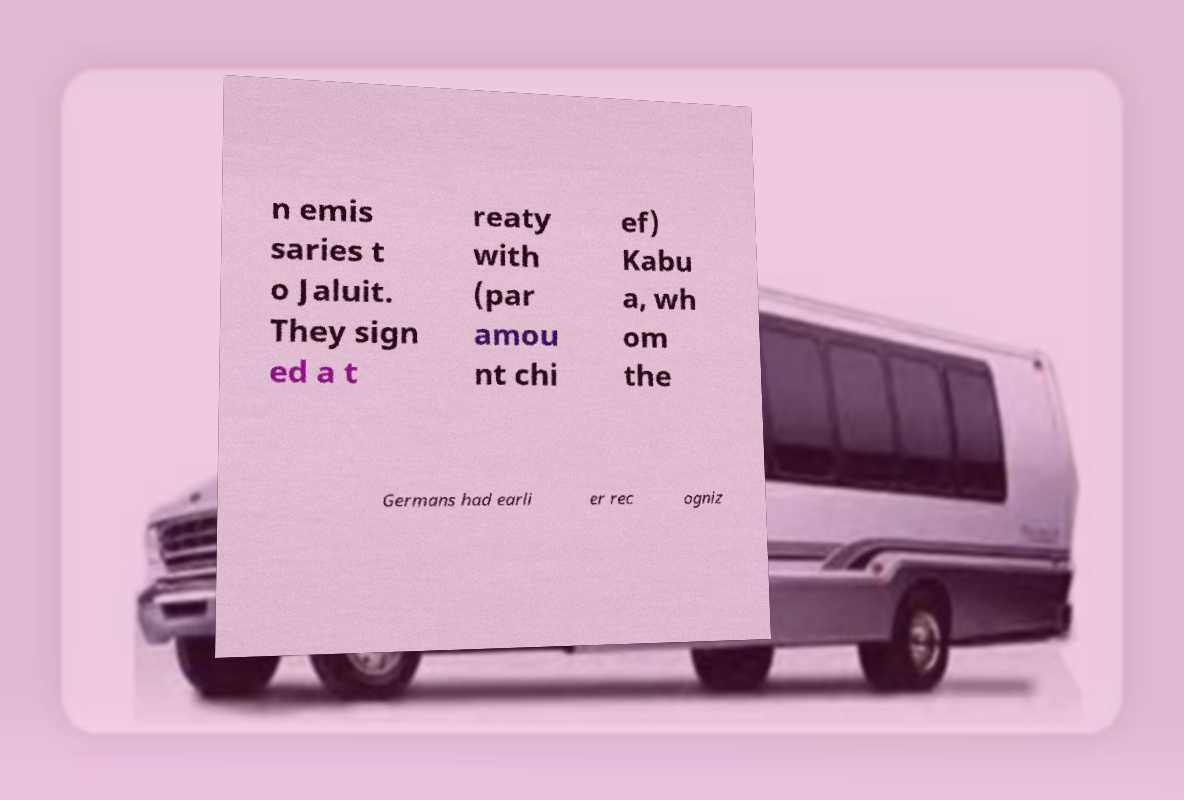Please read and relay the text visible in this image. What does it say? n emis saries t o Jaluit. They sign ed a t reaty with (par amou nt chi ef) Kabu a, wh om the Germans had earli er rec ogniz 